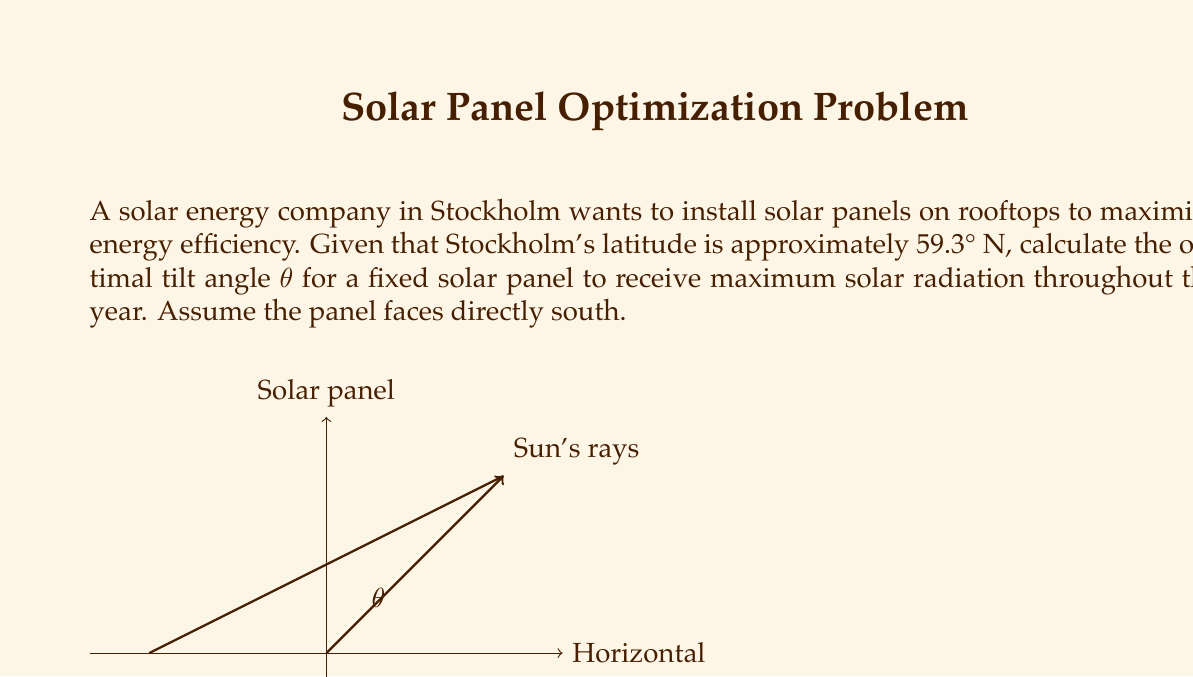Can you answer this question? To find the optimal tilt angle for a fixed solar panel in Stockholm, we can follow these steps:

1. The general rule of thumb for optimal tilt angle is:
   $$ \text{Optimal tilt angle} = \text{Latitude} - 15° $$

2. This rule is based on the fact that the sun's position in the sky changes throughout the year, and this angle provides a good compromise for year-round performance.

3. For Stockholm:
   $$ \text{Latitude} = 59.3° \text{ N} $$

4. Applying the formula:
   $$ \text{Optimal tilt angle} = 59.3° - 15° = 44.3° $$

5. Therefore, the optimal tilt angle θ for a fixed solar panel in Stockholm is approximately 44.3° from the horizontal, facing south.

Note: This is a simplified calculation. In practice, other factors such as local weather patterns, shading, and specific energy demand profiles might slightly adjust this angle.
Answer: $44.3°$ 